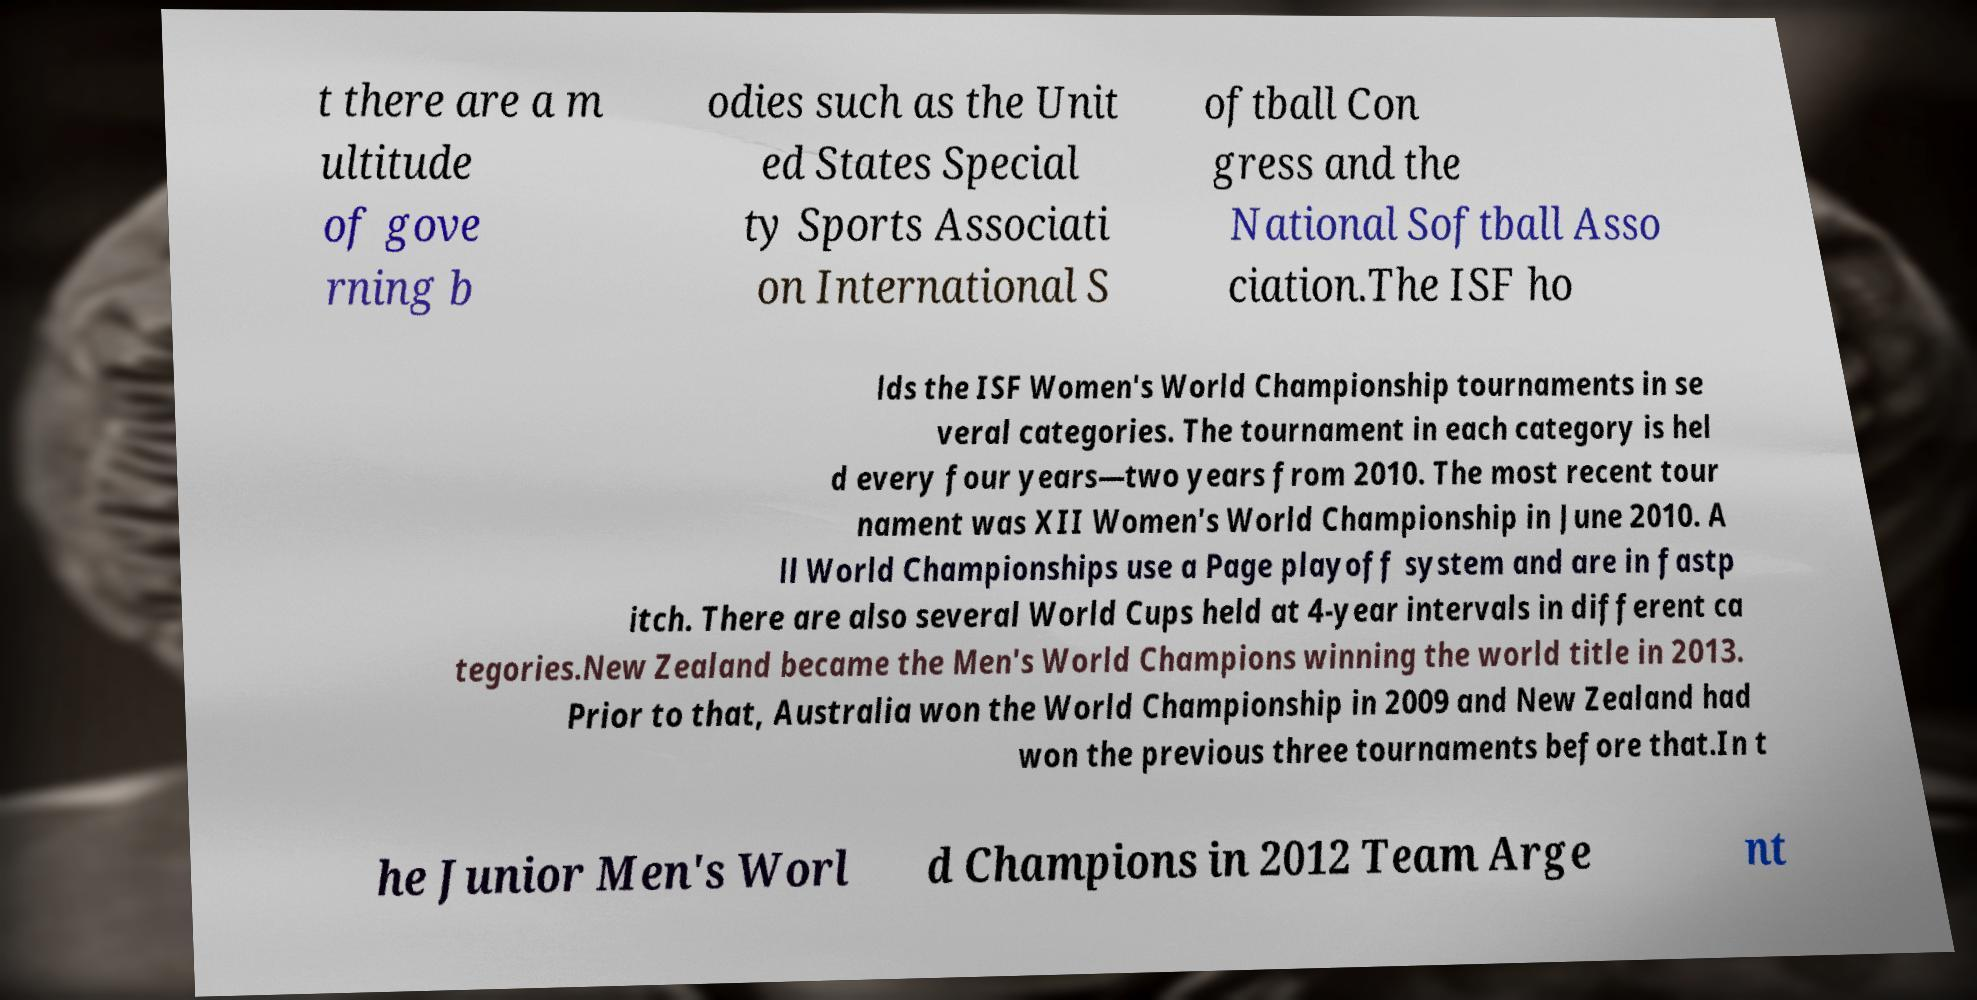Could you assist in decoding the text presented in this image and type it out clearly? t there are a m ultitude of gove rning b odies such as the Unit ed States Special ty Sports Associati on International S oftball Con gress and the National Softball Asso ciation.The ISF ho lds the ISF Women's World Championship tournaments in se veral categories. The tournament in each category is hel d every four years—two years from 2010. The most recent tour nament was XII Women's World Championship in June 2010. A ll World Championships use a Page playoff system and are in fastp itch. There are also several World Cups held at 4-year intervals in different ca tegories.New Zealand became the Men's World Champions winning the world title in 2013. Prior to that, Australia won the World Championship in 2009 and New Zealand had won the previous three tournaments before that.In t he Junior Men's Worl d Champions in 2012 Team Arge nt 